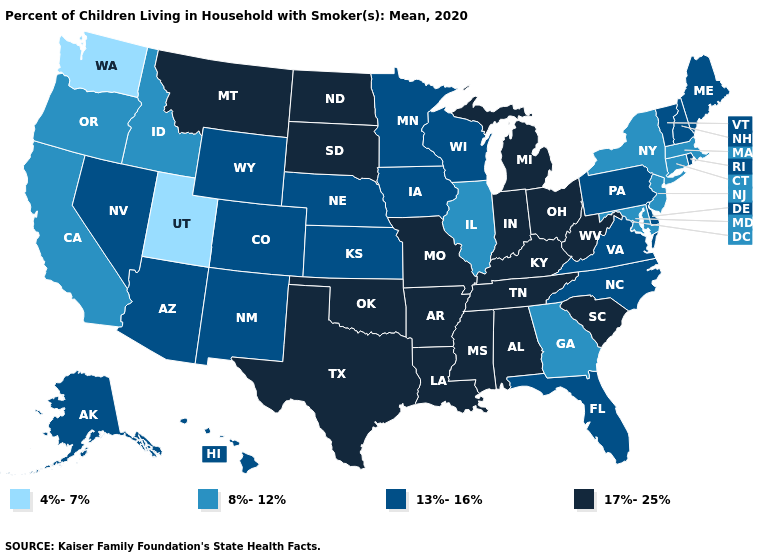What is the lowest value in the USA?
Answer briefly. 4%-7%. Does Pennsylvania have a higher value than Massachusetts?
Give a very brief answer. Yes. Does the first symbol in the legend represent the smallest category?
Write a very short answer. Yes. Which states have the lowest value in the MidWest?
Answer briefly. Illinois. Which states have the highest value in the USA?
Give a very brief answer. Alabama, Arkansas, Indiana, Kentucky, Louisiana, Michigan, Mississippi, Missouri, Montana, North Dakota, Ohio, Oklahoma, South Carolina, South Dakota, Tennessee, Texas, West Virginia. Does West Virginia have the lowest value in the South?
Write a very short answer. No. Which states have the lowest value in the USA?
Quick response, please. Utah, Washington. What is the highest value in states that border Delaware?
Write a very short answer. 13%-16%. Name the states that have a value in the range 4%-7%?
Answer briefly. Utah, Washington. What is the lowest value in states that border Pennsylvania?
Be succinct. 8%-12%. Does Pennsylvania have a lower value than California?
Write a very short answer. No. Name the states that have a value in the range 13%-16%?
Give a very brief answer. Alaska, Arizona, Colorado, Delaware, Florida, Hawaii, Iowa, Kansas, Maine, Minnesota, Nebraska, Nevada, New Hampshire, New Mexico, North Carolina, Pennsylvania, Rhode Island, Vermont, Virginia, Wisconsin, Wyoming. What is the lowest value in states that border Arizona?
Quick response, please. 4%-7%. Which states have the highest value in the USA?
Give a very brief answer. Alabama, Arkansas, Indiana, Kentucky, Louisiana, Michigan, Mississippi, Missouri, Montana, North Dakota, Ohio, Oklahoma, South Carolina, South Dakota, Tennessee, Texas, West Virginia. Does Vermont have a lower value than Delaware?
Short answer required. No. 